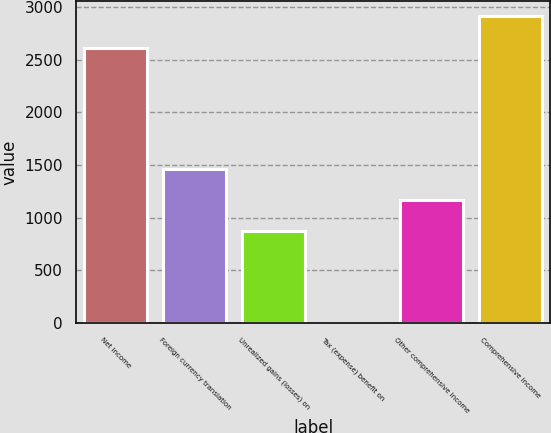Convert chart to OTSL. <chart><loc_0><loc_0><loc_500><loc_500><bar_chart><fcel>Net income<fcel>Foreign currency translation<fcel>Unrealized gains (losses) on<fcel>Tax (expense) benefit on<fcel>Other comprehensive income<fcel>Comprehensive income<nl><fcel>2609<fcel>1460<fcel>877.6<fcel>4<fcel>1168.8<fcel>2916<nl></chart> 